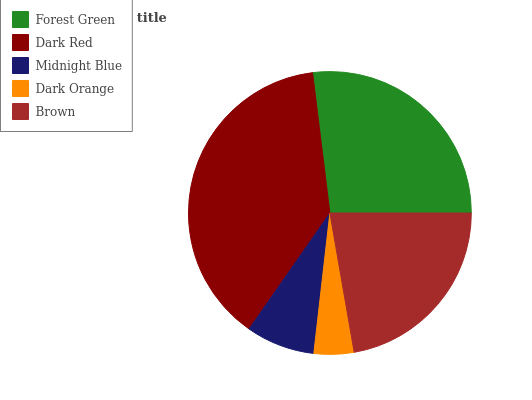Is Dark Orange the minimum?
Answer yes or no. Yes. Is Dark Red the maximum?
Answer yes or no. Yes. Is Midnight Blue the minimum?
Answer yes or no. No. Is Midnight Blue the maximum?
Answer yes or no. No. Is Dark Red greater than Midnight Blue?
Answer yes or no. Yes. Is Midnight Blue less than Dark Red?
Answer yes or no. Yes. Is Midnight Blue greater than Dark Red?
Answer yes or no. No. Is Dark Red less than Midnight Blue?
Answer yes or no. No. Is Brown the high median?
Answer yes or no. Yes. Is Brown the low median?
Answer yes or no. Yes. Is Dark Red the high median?
Answer yes or no. No. Is Dark Orange the low median?
Answer yes or no. No. 